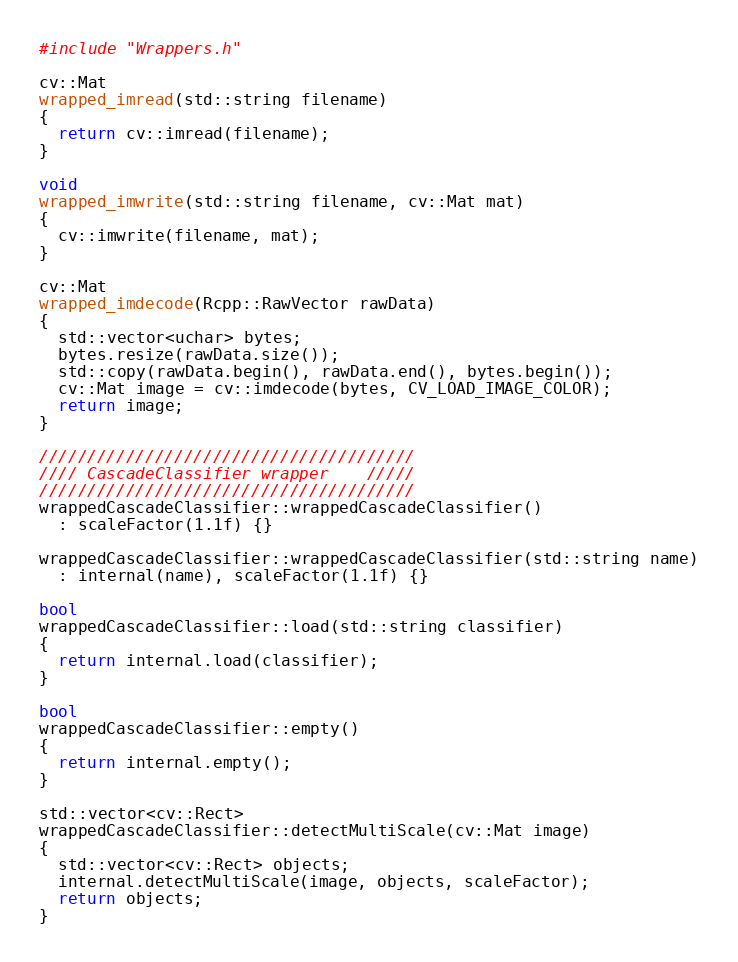<code> <loc_0><loc_0><loc_500><loc_500><_C++_>#include "Wrappers.h"

cv::Mat 
wrapped_imread(std::string filename)
{
  return cv::imread(filename);
}

void 
wrapped_imwrite(std::string filename, cv::Mat mat)
{
  cv::imwrite(filename, mat);
}

cv::Mat
wrapped_imdecode(Rcpp::RawVector rawData)
{
  std::vector<uchar> bytes;
  bytes.resize(rawData.size());
  std::copy(rawData.begin(), rawData.end(), bytes.begin());
  cv::Mat image = cv::imdecode(bytes, CV_LOAD_IMAGE_COLOR);
  return image;
}

///////////////////////////////////////
//// CascadeClassifier wrapper    /////
///////////////////////////////////////
wrappedCascadeClassifier::wrappedCascadeClassifier()
  : scaleFactor(1.1f) {}

wrappedCascadeClassifier::wrappedCascadeClassifier(std::string name)
  : internal(name), scaleFactor(1.1f) {}

bool
wrappedCascadeClassifier::load(std::string classifier)
{
  return internal.load(classifier);
}

bool
wrappedCascadeClassifier::empty()
{
  return internal.empty();
}

std::vector<cv::Rect> 
wrappedCascadeClassifier::detectMultiScale(cv::Mat image)
{
  std::vector<cv::Rect> objects;
  internal.detectMultiScale(image, objects, scaleFactor);
  return objects;
}




</code> 